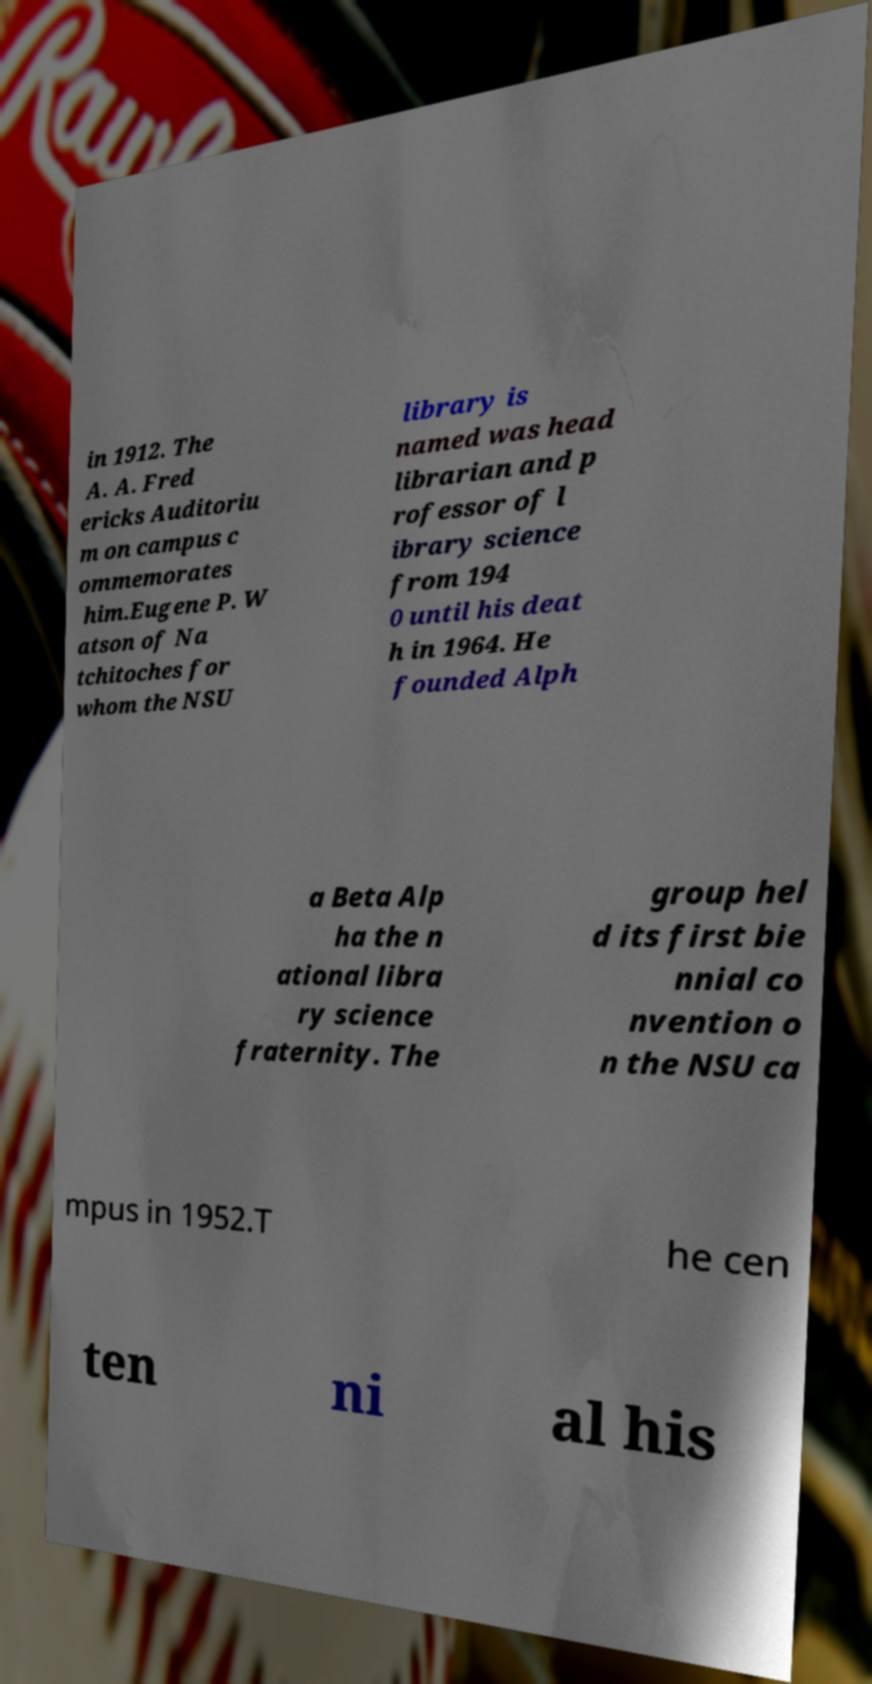I need the written content from this picture converted into text. Can you do that? in 1912. The A. A. Fred ericks Auditoriu m on campus c ommemorates him.Eugene P. W atson of Na tchitoches for whom the NSU library is named was head librarian and p rofessor of l ibrary science from 194 0 until his deat h in 1964. He founded Alph a Beta Alp ha the n ational libra ry science fraternity. The group hel d its first bie nnial co nvention o n the NSU ca mpus in 1952.T he cen ten ni al his 